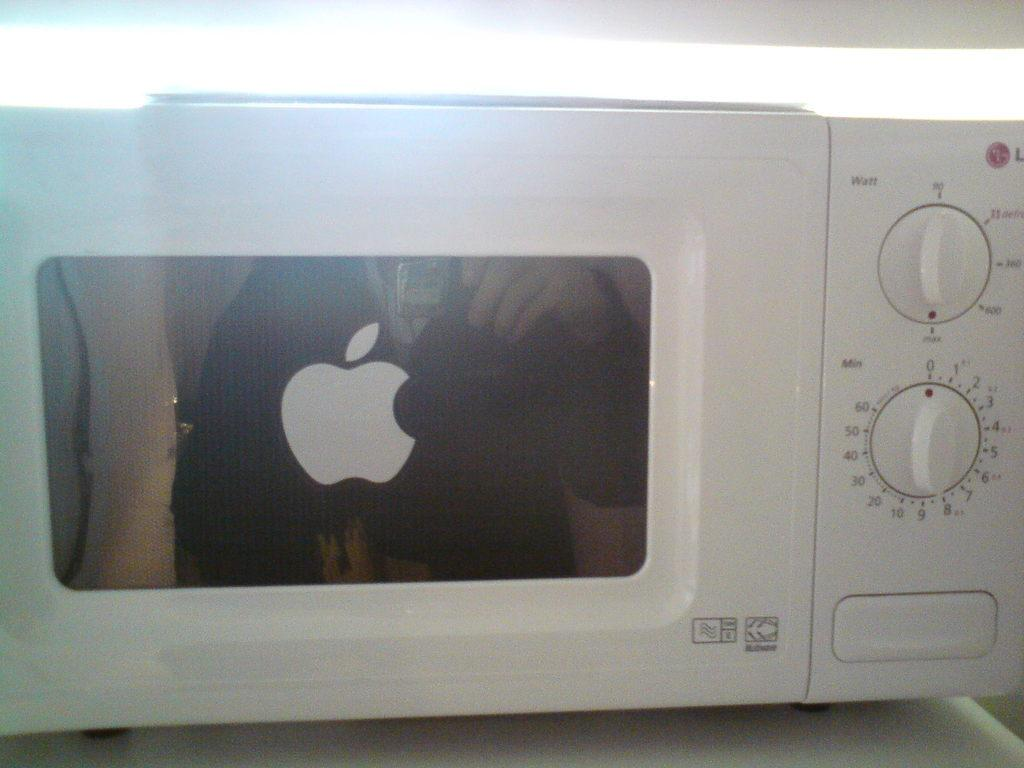<image>
Render a clear and concise summary of the photo. A white microwave with two dials one of which says watts 